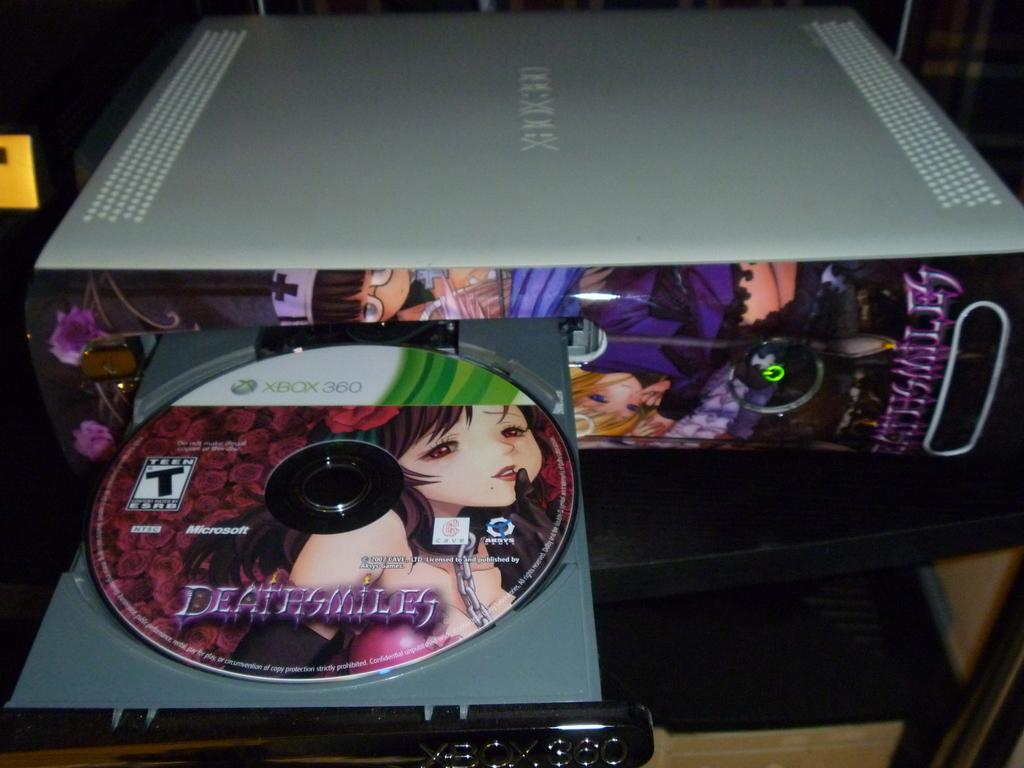What type of device is present in the image? There is a device with a cassette in the image. What material can be seen in the image? Wood is visible in the image. Can you describe the object in the bottom right corner of the image? Unfortunately, the facts provided do not give enough information to describe the object in the bottom right corner of the image. How does the device with a cassette smash the sense of structure in the image? The device with a cassette does not smash the sense of structure in the image, as there is no indication of any destruction or disruption in the image. 